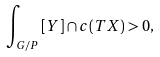Convert formula to latex. <formula><loc_0><loc_0><loc_500><loc_500>\int _ { G / P } { [ Y ] \cap c ( T X ) } > 0 ,</formula> 